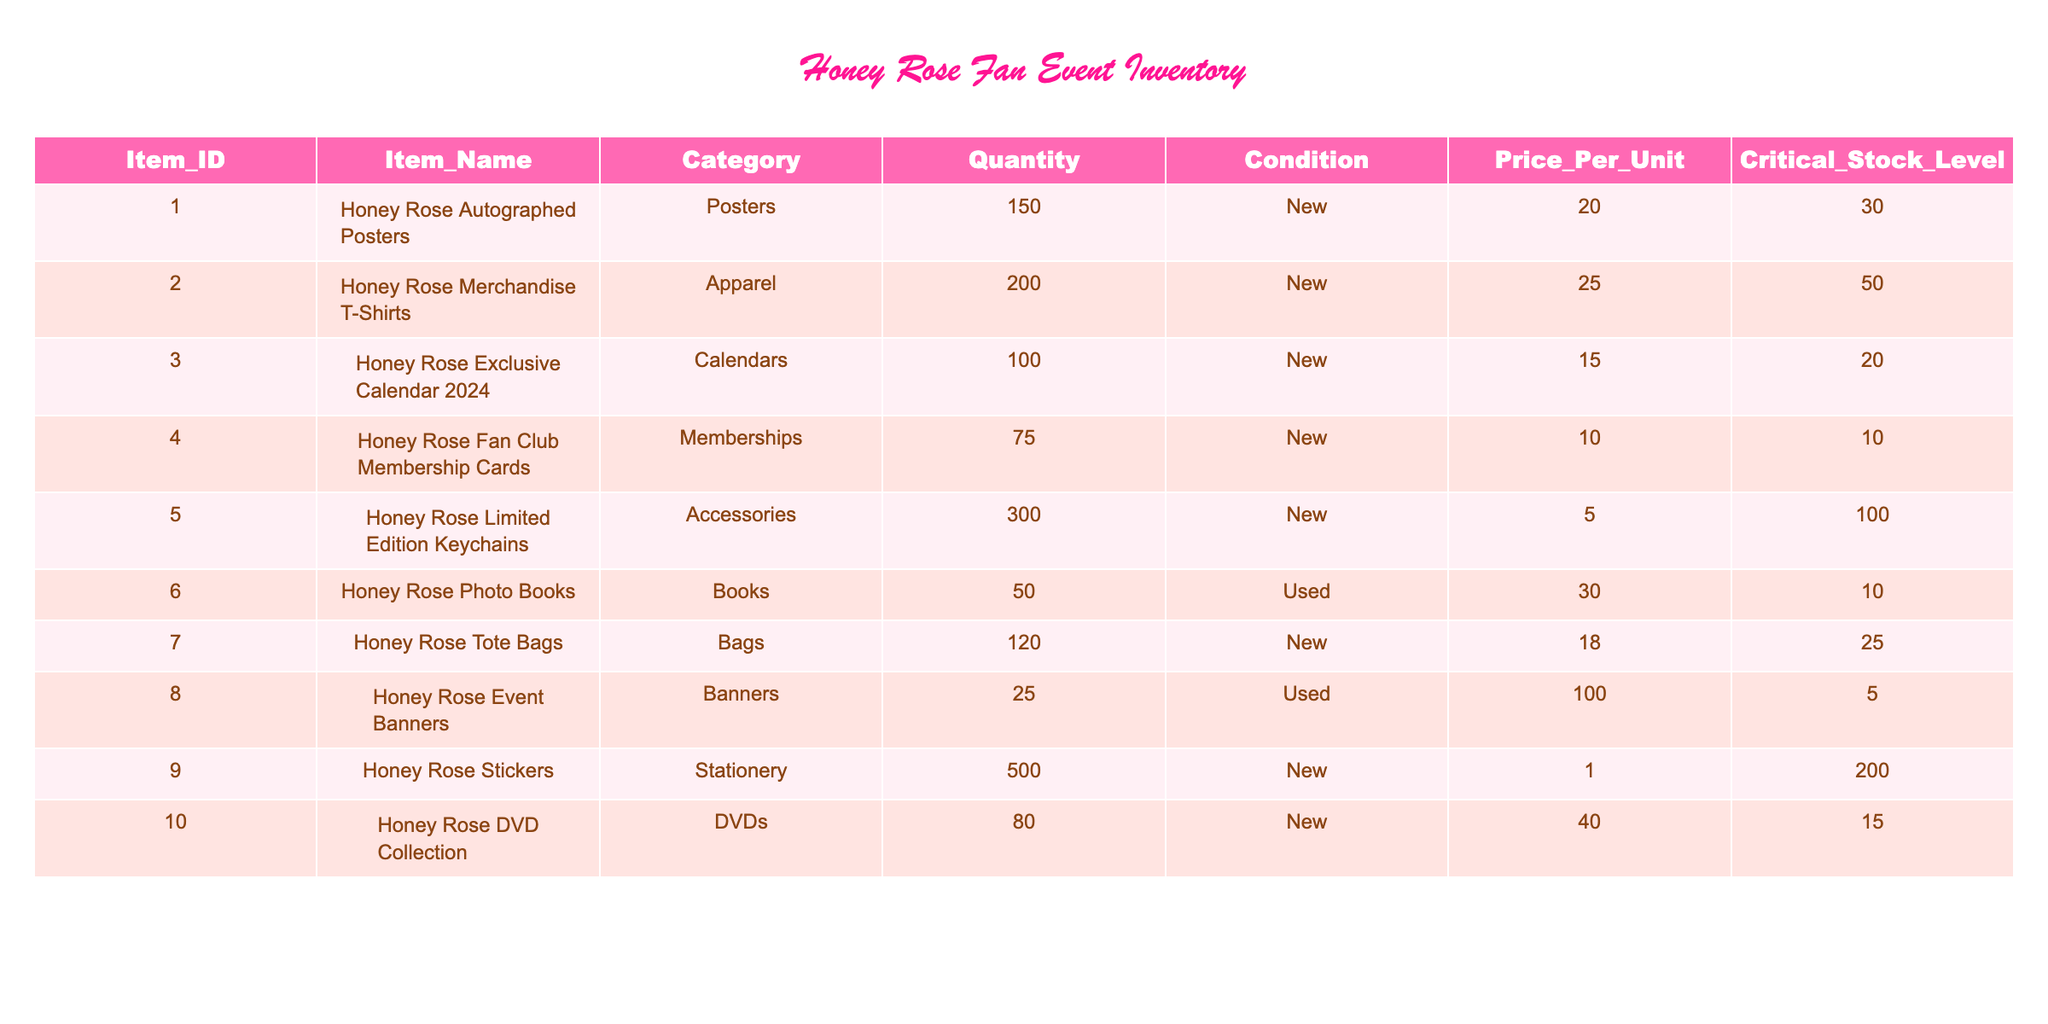What is the total quantity of Honey Rose autographed posters available? The quantity of Honey Rose autographed posters is explicitly listed in the table under the "Quantity" column, which shows a value of 150.
Answer: 150 How many items are in the "Memberships" category? In the "Category" column, we can see that "Memberships" is listed with a quantity of 75. This means that there are 75 items in that category.
Answer: 75 Is there an item with "Used" condition that has a critical stock level greater than 10? Checking the "Condition" and "Critical Stock Level" columns, the only item listed as "Used" is the Honey Rose Photo Books, which has a critical stock level of 10. Therefore, there is no item in "Used" condition exceeding a critical stock level of 10.
Answer: No What is the combined quantity of Honey Rose merchandise T-shirts and tote bags? To find the combined quantity, we add the quantities of Honey Rose merchandise T-shirts (200) and tote bags (120) from the "Quantity" column: 200 + 120 = 320.
Answer: 320 Are there more than 250 stickers available? Referring to the "Quantity" column, we see that there are 500 Honey Rose stickers available. Since this value is greater than 250, the answer is yes.
Answer: Yes What is the average price per unit for all items in the inventory? To calculate the average price, we first sum the prices per unit: 20.00 + 25.00 + 15.00 + 10.00 + 5.00 + 30.00 + 18.00 + 100.00 + 1.00 + 40.00 = 250.00. There are 10 items in total, so the average price is 250.00 / 10 = 25.00.
Answer: 25.00 Which item has the highest price per unit? Looking at the "Price Per Unit" column, the highest value is listed as 100.00 for the Honey Rose Event Banners.
Answer: Honey Rose Event Banners How many keychains must be sold to reach the critical stock level? The critical stock level for Honey Rose limited edition keychains is 100, and the current quantity is 300. To reach the critical stock level, we compare the two values: 100 - 300 = -200. Since this is negative, it means no additional keychains need to be sold to meet that level.
Answer: 0 